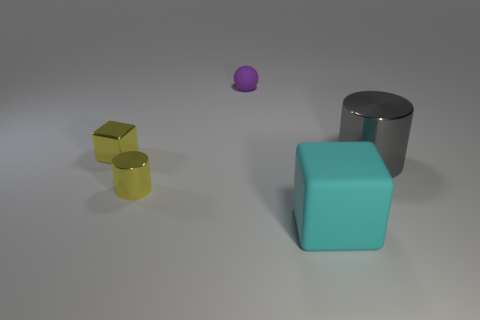The metallic thing that is the same color as the tiny block is what shape?
Keep it short and to the point. Cylinder. There is a shiny cylinder that is to the right of the small sphere; what is its size?
Provide a succinct answer. Large. What shape is the small yellow thing that is made of the same material as the yellow cylinder?
Your answer should be compact. Cube. Do the gray object and the cylinder left of the tiny purple rubber sphere have the same material?
Your answer should be very brief. Yes. There is a small yellow thing that is behind the tiny yellow cylinder; does it have the same shape as the big gray object?
Your response must be concise. No. There is a cyan thing; is its shape the same as the yellow metal object that is behind the yellow shiny cylinder?
Provide a short and direct response. Yes. There is a thing that is both behind the big cyan block and in front of the big cylinder; what is its color?
Your answer should be compact. Yellow. Are there any big yellow shiny cubes?
Provide a succinct answer. No. Are there an equal number of large cyan cubes that are left of the small purple thing and tiny rubber objects?
Provide a short and direct response. No. How many other things are there of the same shape as the small purple thing?
Your answer should be compact. 0. 